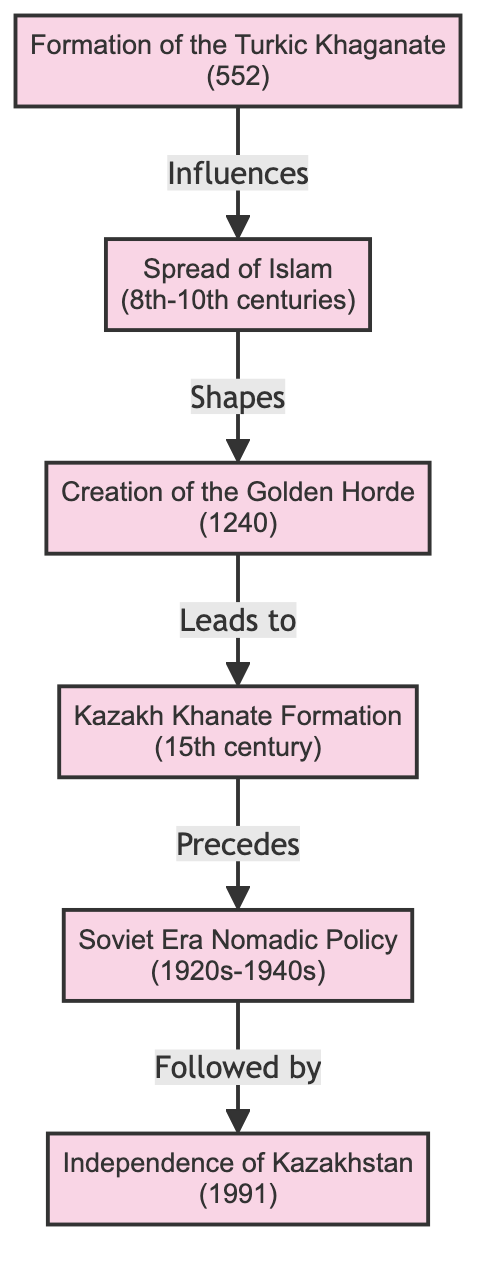What significant event occurred in 552? The event that occurred in 552 is the Formation of the Turkic Khaganate, as indicated directly in the diagram with the corresponding year and description.
Answer: Formation of the Turkic Khaganate Which event leads to the formation of the Kazakh Khanate? The event that leads to the formation of the Kazakh Khanate is the Creation of the Golden Horde, as shown by the directed arrow leading from the Golden Horde to the Kazakh Khanate in the diagram.
Answer: Creation of the Golden Horde How many events are included in the diagram? The diagram consists of six events, which can be counted directly from the nodes listed in the diagram.
Answer: 6 What event precedes the Soviet Era Nomadic Policy? The event that precedes the Soviet Era Nomadic Policy is the Kazakh Khanate Formation, as indicated by the directed arrow flowing from the Kazakh Khanate to the Soviet Era Nomadic Policy in the diagram.
Answer: Kazakh Khanate Formation What is the relationship between the Spread of Islam and the Creation of the Golden Horde? The relationship is that the Spread of Islam shapes the Creation of the Golden Horde, indicated by the directional arrow labeled "Shapes" connecting these two events in the diagram.
Answer: Shapes Which event follows the Independence of Kazakhstan? There are no events following the Independence of Kazakhstan; it is the last event in the timeline, which is evident as there are no arrows directed out of this node in the diagram.
Answer: None 